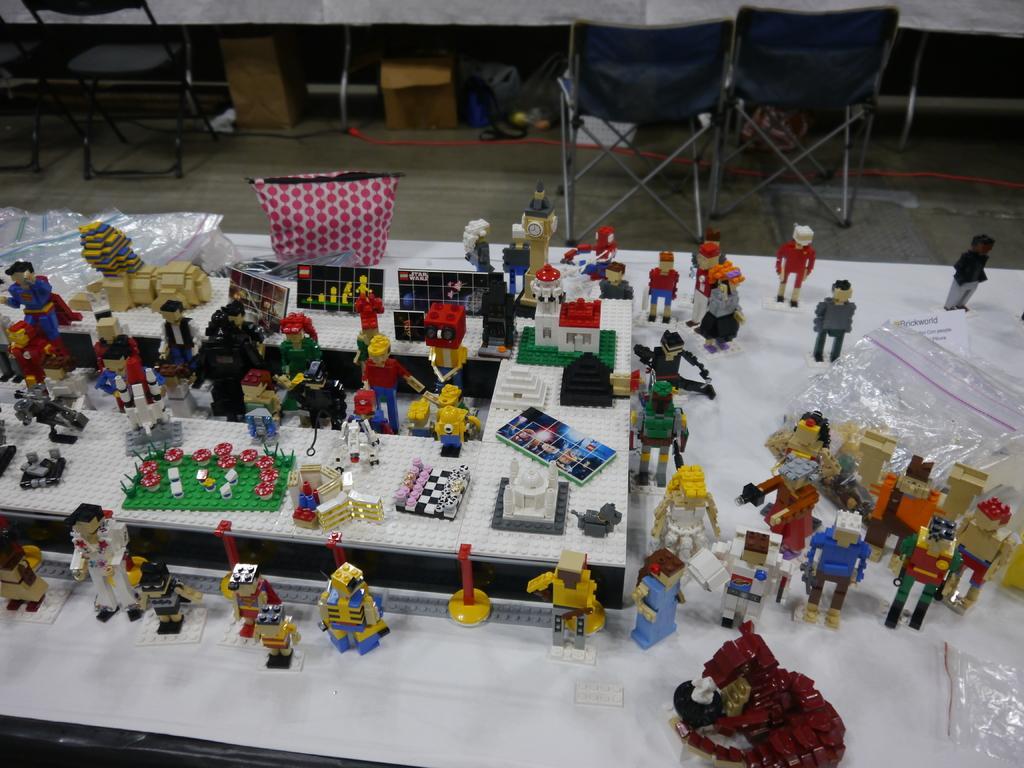How would you summarize this image in a sentence or two? In the picture I can see toys, covers and some other objects on a table. In the background I can see chairs and some other objects. 